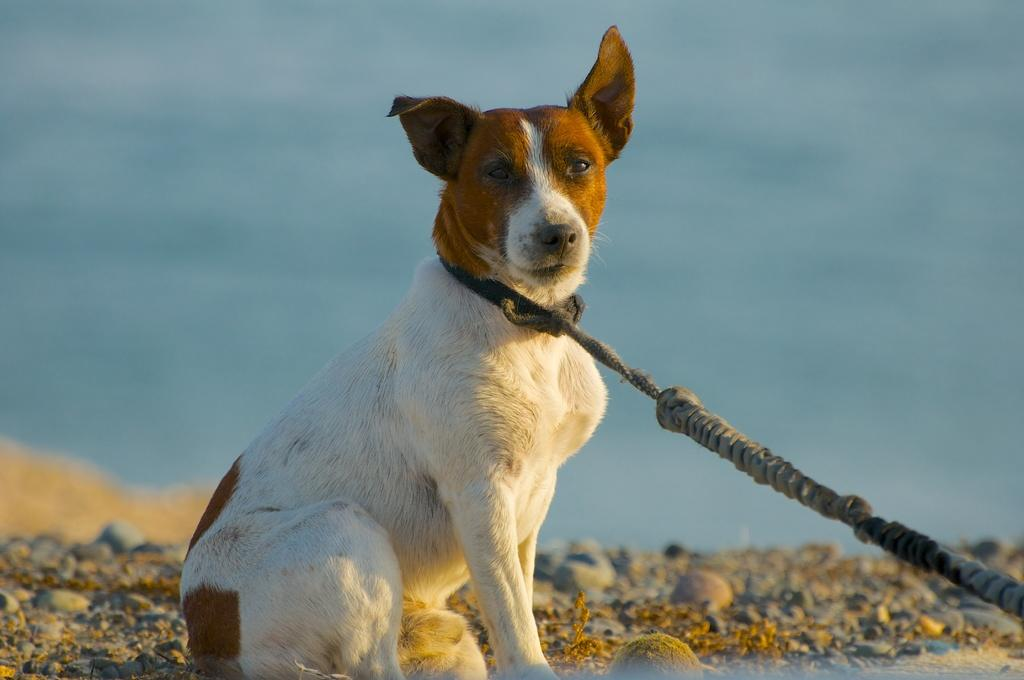What type of animal can be seen in the image? There is a dog in the image. Where is the dog located? The dog is sitting on the land. What is the terrain like where the dog is sitting? The land has rocks. How is the dog restrained in the image? The dog is tied with a chain. What can be seen in the distance in the image? There is water visible in the background of the image. What hour of the day is the stranger visiting the dog in the image? There is no stranger present in the image, so it is not possible to determine the hour of their visit. 